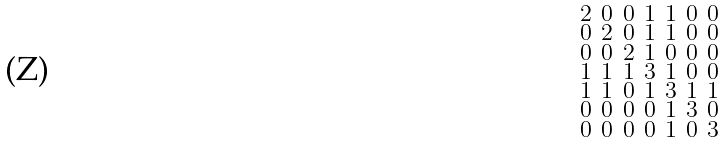Convert formula to latex. <formula><loc_0><loc_0><loc_500><loc_500>\begin{smallmatrix} 2 & 0 & 0 & 1 & 1 & 0 & 0 \\ 0 & 2 & 0 & 1 & 1 & 0 & 0 \\ 0 & 0 & 2 & 1 & 0 & 0 & 0 \\ 1 & 1 & 1 & 3 & 1 & 0 & 0 \\ 1 & 1 & 0 & 1 & 3 & 1 & 1 \\ 0 & 0 & 0 & 0 & 1 & 3 & 0 \\ 0 & 0 & 0 & 0 & 1 & 0 & 3 \end{smallmatrix}</formula> 